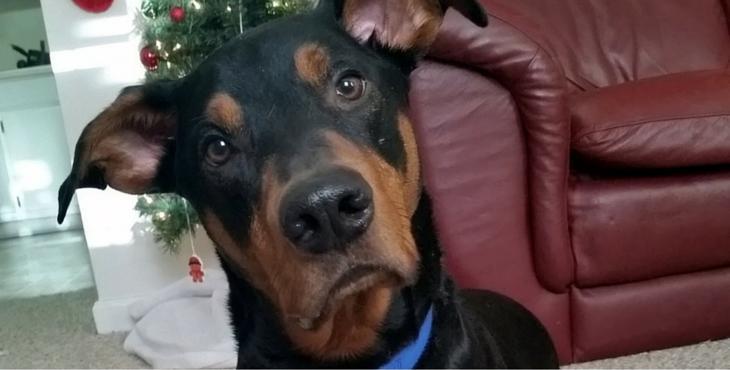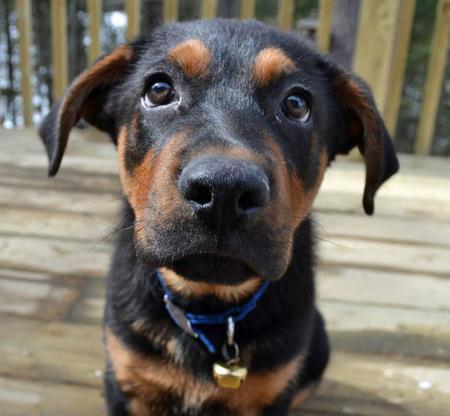The first image is the image on the left, the second image is the image on the right. Assess this claim about the two images: "One of the dogs is looking directly at the camera, and one of the dogs has an open mouth.". Correct or not? Answer yes or no. No. 